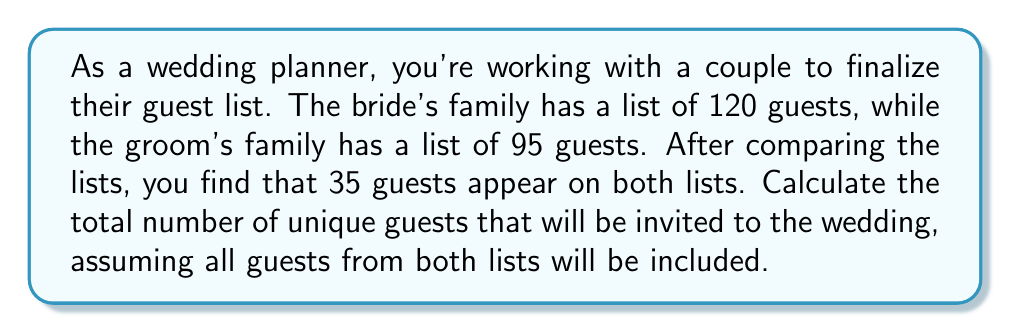Teach me how to tackle this problem. To solve this problem, we need to use the concept of set theory, specifically the union of two sets. Let's break it down step-by-step:

1. Let A be the set of guests from the bride's family, and B be the set of guests from the groom's family.

2. We know:
   $|A| = 120$ (number of guests in bride's list)
   $|B| = 95$ (number of guests in groom's list)
   $|A \cap B| = 35$ (number of guests that appear in both lists)

3. We need to find $|A \cup B|$, which represents the total number of unique guests.

4. The formula for the union of two sets is:
   $$|A \cup B| = |A| + |B| - |A \cap B|$$

5. This formula accounts for the overlap between the two sets, ensuring we don't count the common guests twice.

6. Substituting the values:
   $$|A \cup B| = 120 + 95 - 35$$

7. Calculating:
   $$|A \cup B| = 215 - 35 = 180$$

Therefore, the total number of unique guests to be invited to the wedding is 180.
Answer: 180 guests 